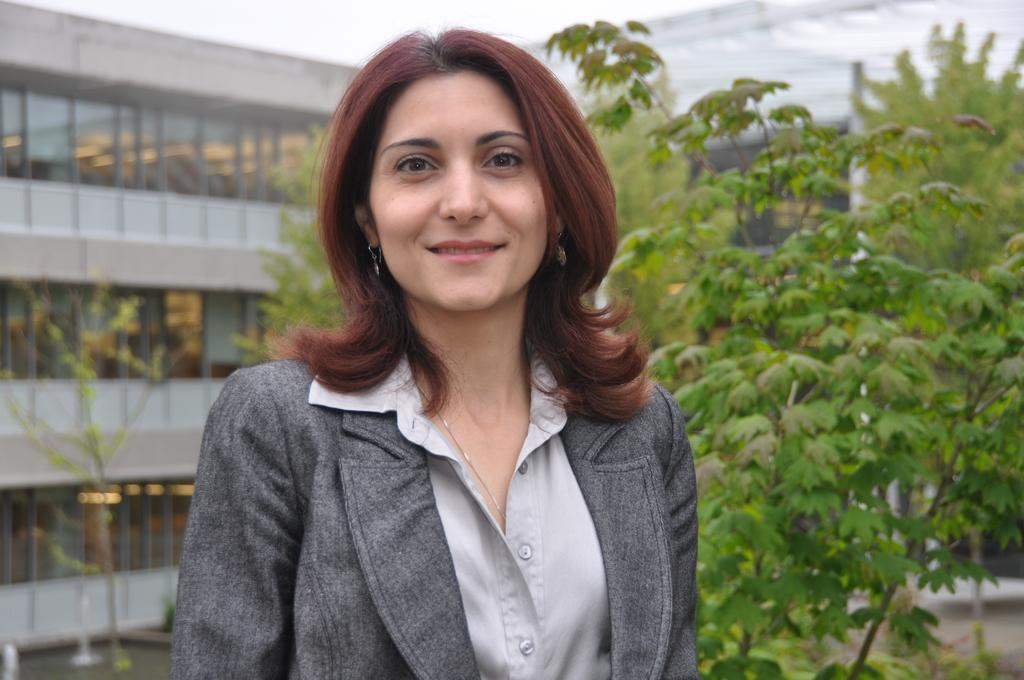Who is the main subject in the image? There is a woman in the center of the image. What can be seen in the background of the image? There is a building, plants, trees, and the sky visible in the background of the image. What type of tools does the carpenter use in the image? There is no carpenter present in the image, so it is not possible to answer that question. 